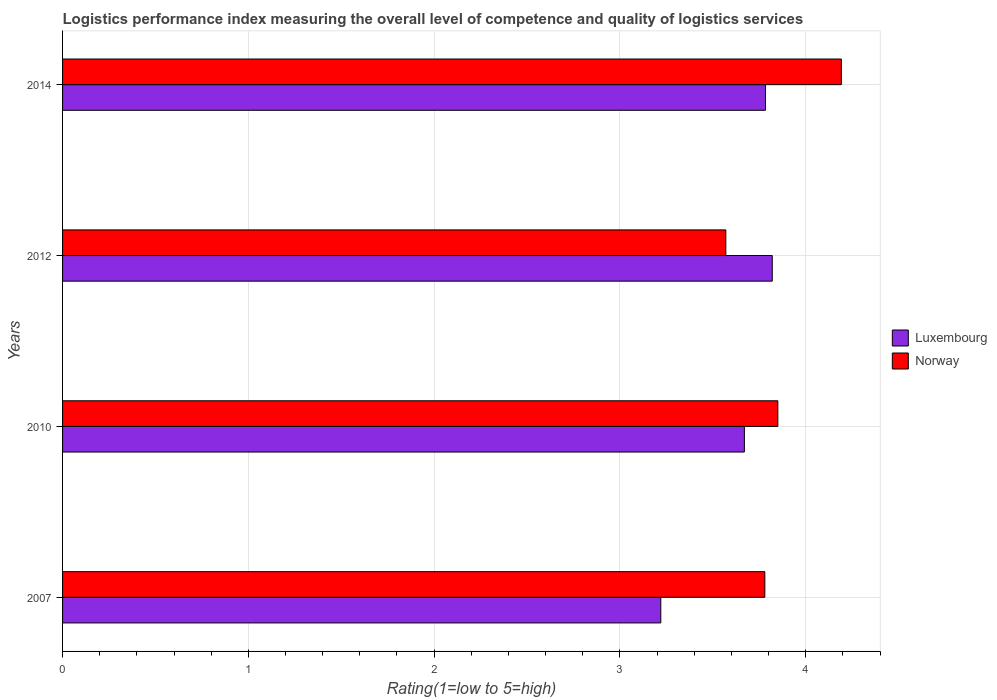How many different coloured bars are there?
Give a very brief answer. 2. Are the number of bars per tick equal to the number of legend labels?
Ensure brevity in your answer.  Yes. How many bars are there on the 3rd tick from the top?
Give a very brief answer. 2. What is the Logistic performance index in Luxembourg in 2007?
Give a very brief answer. 3.22. Across all years, what is the maximum Logistic performance index in Norway?
Your response must be concise. 4.19. Across all years, what is the minimum Logistic performance index in Luxembourg?
Offer a terse response. 3.22. In which year was the Logistic performance index in Luxembourg minimum?
Offer a terse response. 2007. What is the total Logistic performance index in Luxembourg in the graph?
Offer a very short reply. 14.49. What is the difference between the Logistic performance index in Luxembourg in 2010 and that in 2014?
Offer a terse response. -0.11. What is the difference between the Logistic performance index in Norway in 2010 and the Logistic performance index in Luxembourg in 2014?
Keep it short and to the point. 0.07. What is the average Logistic performance index in Luxembourg per year?
Offer a terse response. 3.62. In the year 2014, what is the difference between the Logistic performance index in Norway and Logistic performance index in Luxembourg?
Give a very brief answer. 0.41. What is the ratio of the Logistic performance index in Norway in 2012 to that in 2014?
Your answer should be very brief. 0.85. Is the Logistic performance index in Norway in 2007 less than that in 2014?
Give a very brief answer. Yes. Is the difference between the Logistic performance index in Norway in 2012 and 2014 greater than the difference between the Logistic performance index in Luxembourg in 2012 and 2014?
Your answer should be very brief. No. What is the difference between the highest and the second highest Logistic performance index in Luxembourg?
Offer a very short reply. 0.04. What is the difference between the highest and the lowest Logistic performance index in Norway?
Provide a succinct answer. 0.62. Is the sum of the Logistic performance index in Luxembourg in 2012 and 2014 greater than the maximum Logistic performance index in Norway across all years?
Your answer should be very brief. Yes. What does the 2nd bar from the bottom in 2010 represents?
Keep it short and to the point. Norway. Are all the bars in the graph horizontal?
Give a very brief answer. Yes. How many years are there in the graph?
Keep it short and to the point. 4. What is the difference between two consecutive major ticks on the X-axis?
Make the answer very short. 1. Are the values on the major ticks of X-axis written in scientific E-notation?
Offer a terse response. No. Does the graph contain grids?
Your answer should be compact. Yes. How many legend labels are there?
Your response must be concise. 2. What is the title of the graph?
Give a very brief answer. Logistics performance index measuring the overall level of competence and quality of logistics services. Does "Bahrain" appear as one of the legend labels in the graph?
Keep it short and to the point. No. What is the label or title of the X-axis?
Give a very brief answer. Rating(1=low to 5=high). What is the label or title of the Y-axis?
Your answer should be compact. Years. What is the Rating(1=low to 5=high) in Luxembourg in 2007?
Offer a terse response. 3.22. What is the Rating(1=low to 5=high) in Norway in 2007?
Your answer should be compact. 3.78. What is the Rating(1=low to 5=high) of Luxembourg in 2010?
Keep it short and to the point. 3.67. What is the Rating(1=low to 5=high) in Norway in 2010?
Your response must be concise. 3.85. What is the Rating(1=low to 5=high) in Luxembourg in 2012?
Keep it short and to the point. 3.82. What is the Rating(1=low to 5=high) in Norway in 2012?
Provide a short and direct response. 3.57. What is the Rating(1=low to 5=high) in Luxembourg in 2014?
Your answer should be very brief. 3.78. What is the Rating(1=low to 5=high) of Norway in 2014?
Keep it short and to the point. 4.19. Across all years, what is the maximum Rating(1=low to 5=high) of Luxembourg?
Keep it short and to the point. 3.82. Across all years, what is the maximum Rating(1=low to 5=high) of Norway?
Provide a short and direct response. 4.19. Across all years, what is the minimum Rating(1=low to 5=high) of Luxembourg?
Your answer should be compact. 3.22. Across all years, what is the minimum Rating(1=low to 5=high) in Norway?
Your answer should be compact. 3.57. What is the total Rating(1=low to 5=high) in Luxembourg in the graph?
Your response must be concise. 14.49. What is the total Rating(1=low to 5=high) in Norway in the graph?
Your answer should be compact. 15.39. What is the difference between the Rating(1=low to 5=high) of Luxembourg in 2007 and that in 2010?
Ensure brevity in your answer.  -0.45. What is the difference between the Rating(1=low to 5=high) in Norway in 2007 and that in 2010?
Give a very brief answer. -0.07. What is the difference between the Rating(1=low to 5=high) of Luxembourg in 2007 and that in 2012?
Your answer should be compact. -0.6. What is the difference between the Rating(1=low to 5=high) of Norway in 2007 and that in 2012?
Ensure brevity in your answer.  0.21. What is the difference between the Rating(1=low to 5=high) in Luxembourg in 2007 and that in 2014?
Provide a short and direct response. -0.56. What is the difference between the Rating(1=low to 5=high) in Norway in 2007 and that in 2014?
Offer a terse response. -0.41. What is the difference between the Rating(1=low to 5=high) in Norway in 2010 and that in 2012?
Offer a very short reply. 0.28. What is the difference between the Rating(1=low to 5=high) of Luxembourg in 2010 and that in 2014?
Your answer should be compact. -0.11. What is the difference between the Rating(1=low to 5=high) in Norway in 2010 and that in 2014?
Your answer should be very brief. -0.34. What is the difference between the Rating(1=low to 5=high) in Luxembourg in 2012 and that in 2014?
Provide a short and direct response. 0.04. What is the difference between the Rating(1=low to 5=high) of Norway in 2012 and that in 2014?
Your response must be concise. -0.62. What is the difference between the Rating(1=low to 5=high) of Luxembourg in 2007 and the Rating(1=low to 5=high) of Norway in 2010?
Ensure brevity in your answer.  -0.63. What is the difference between the Rating(1=low to 5=high) of Luxembourg in 2007 and the Rating(1=low to 5=high) of Norway in 2012?
Your answer should be compact. -0.35. What is the difference between the Rating(1=low to 5=high) in Luxembourg in 2007 and the Rating(1=low to 5=high) in Norway in 2014?
Your answer should be very brief. -0.97. What is the difference between the Rating(1=low to 5=high) in Luxembourg in 2010 and the Rating(1=low to 5=high) in Norway in 2012?
Give a very brief answer. 0.1. What is the difference between the Rating(1=low to 5=high) of Luxembourg in 2010 and the Rating(1=low to 5=high) of Norway in 2014?
Make the answer very short. -0.52. What is the difference between the Rating(1=low to 5=high) of Luxembourg in 2012 and the Rating(1=low to 5=high) of Norway in 2014?
Make the answer very short. -0.37. What is the average Rating(1=low to 5=high) in Luxembourg per year?
Offer a terse response. 3.62. What is the average Rating(1=low to 5=high) of Norway per year?
Your answer should be compact. 3.85. In the year 2007, what is the difference between the Rating(1=low to 5=high) of Luxembourg and Rating(1=low to 5=high) of Norway?
Your answer should be compact. -0.56. In the year 2010, what is the difference between the Rating(1=low to 5=high) in Luxembourg and Rating(1=low to 5=high) in Norway?
Your answer should be compact. -0.18. In the year 2014, what is the difference between the Rating(1=low to 5=high) of Luxembourg and Rating(1=low to 5=high) of Norway?
Offer a terse response. -0.41. What is the ratio of the Rating(1=low to 5=high) of Luxembourg in 2007 to that in 2010?
Your answer should be very brief. 0.88. What is the ratio of the Rating(1=low to 5=high) of Norway in 2007 to that in 2010?
Make the answer very short. 0.98. What is the ratio of the Rating(1=low to 5=high) of Luxembourg in 2007 to that in 2012?
Keep it short and to the point. 0.84. What is the ratio of the Rating(1=low to 5=high) of Norway in 2007 to that in 2012?
Offer a very short reply. 1.06. What is the ratio of the Rating(1=low to 5=high) of Luxembourg in 2007 to that in 2014?
Make the answer very short. 0.85. What is the ratio of the Rating(1=low to 5=high) of Norway in 2007 to that in 2014?
Give a very brief answer. 0.9. What is the ratio of the Rating(1=low to 5=high) in Luxembourg in 2010 to that in 2012?
Offer a very short reply. 0.96. What is the ratio of the Rating(1=low to 5=high) of Norway in 2010 to that in 2012?
Give a very brief answer. 1.08. What is the ratio of the Rating(1=low to 5=high) of Luxembourg in 2010 to that in 2014?
Offer a terse response. 0.97. What is the ratio of the Rating(1=low to 5=high) of Norway in 2010 to that in 2014?
Your response must be concise. 0.92. What is the ratio of the Rating(1=low to 5=high) of Luxembourg in 2012 to that in 2014?
Your response must be concise. 1.01. What is the ratio of the Rating(1=low to 5=high) in Norway in 2012 to that in 2014?
Make the answer very short. 0.85. What is the difference between the highest and the second highest Rating(1=low to 5=high) of Luxembourg?
Your answer should be compact. 0.04. What is the difference between the highest and the second highest Rating(1=low to 5=high) of Norway?
Your answer should be very brief. 0.34. What is the difference between the highest and the lowest Rating(1=low to 5=high) in Luxembourg?
Offer a very short reply. 0.6. What is the difference between the highest and the lowest Rating(1=low to 5=high) of Norway?
Ensure brevity in your answer.  0.62. 